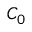Convert formula to latex. <formula><loc_0><loc_0><loc_500><loc_500>C _ { 0 }</formula> 